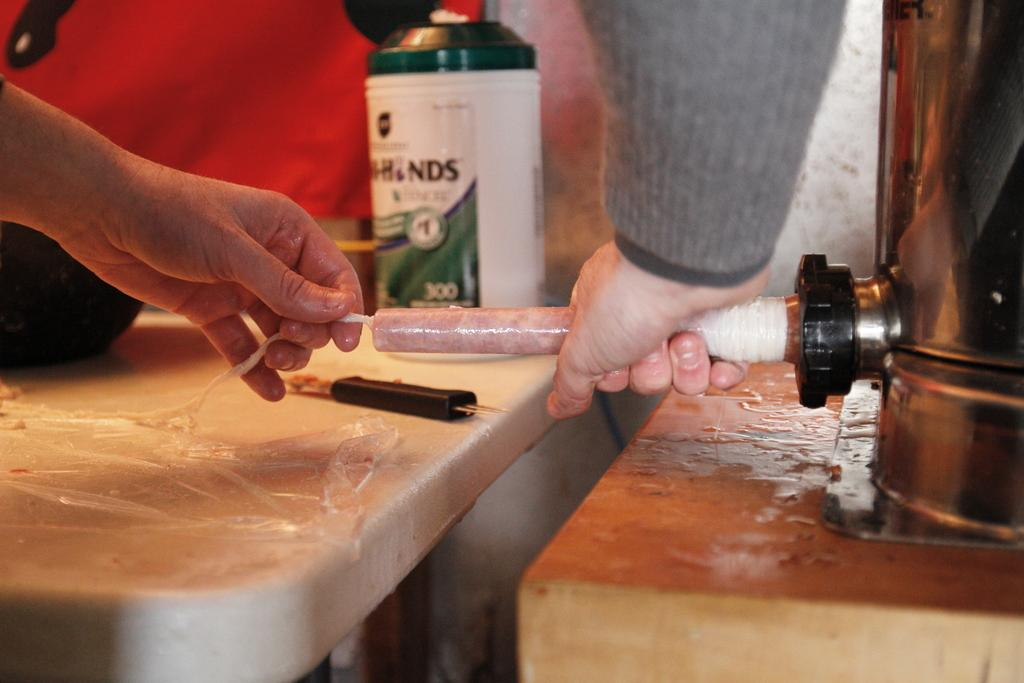<image>
Share a concise interpretation of the image provided. the letters NDS are on the white and green bottle 